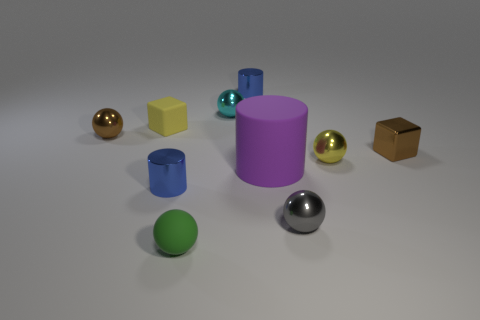Subtract all matte balls. How many balls are left? 4 Subtract all gray balls. How many balls are left? 4 Subtract all purple balls. Subtract all cyan cubes. How many balls are left? 5 Subtract all cylinders. How many objects are left? 7 Subtract all yellow objects. Subtract all big cylinders. How many objects are left? 7 Add 5 tiny green objects. How many tiny green objects are left? 6 Add 9 large things. How many large things exist? 10 Subtract 0 purple balls. How many objects are left? 10 